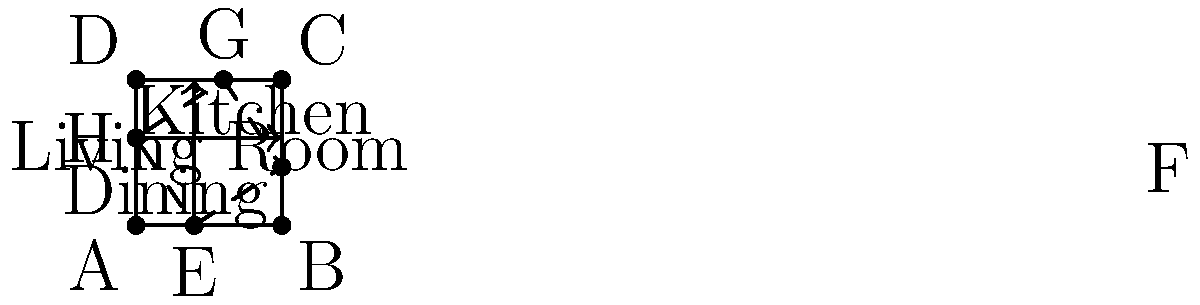In the open-concept living space shown above, where the dashed line represents the main traffic flow, calculate the angle θ between the two primary traffic vectors $\vec{EG}$ and $\vec{HF}$ to optimize movement through the space. Express your answer in degrees. To find the angle between the two traffic vectors, we'll follow these steps:

1. Determine the coordinates of the points:
   E(40, 0), G(60, 100), H(0, 60), F(100, 40)

2. Calculate the vectors $\vec{EG}$ and $\vec{HF}$:
   $\vec{EG} = (60-40, 100-0) = (20, 100)$
   $\vec{HF} = (100-0, 40-60) = (100, -20)$

3. Use the dot product formula to find the angle:
   $\cos \theta = \frac{\vec{EG} \cdot \vec{HF}}{|\vec{EG}| |\vec{HF}|}$

4. Calculate the dot product:
   $\vec{EG} \cdot \vec{HF} = (20)(100) + (100)(-20) = 0$

5. Calculate the magnitudes:
   $|\vec{EG}| = \sqrt{20^2 + 100^2} = \sqrt{10400} = 20\sqrt{26}$
   $|\vec{HF}| = \sqrt{100^2 + (-20)^2} = \sqrt{10400} = 20\sqrt{26}$

6. Substitute into the formula:
   $\cos \theta = \frac{0}{(20\sqrt{26})(20\sqrt{26})} = 0$

7. Solve for θ:
   $\theta = \arccos(0) = 90°$

The angle between the two traffic vectors is 90°, which is optimal for traffic flow as it minimizes congestion and allows for smooth movement between different areas of the open-concept space.
Answer: 90° 